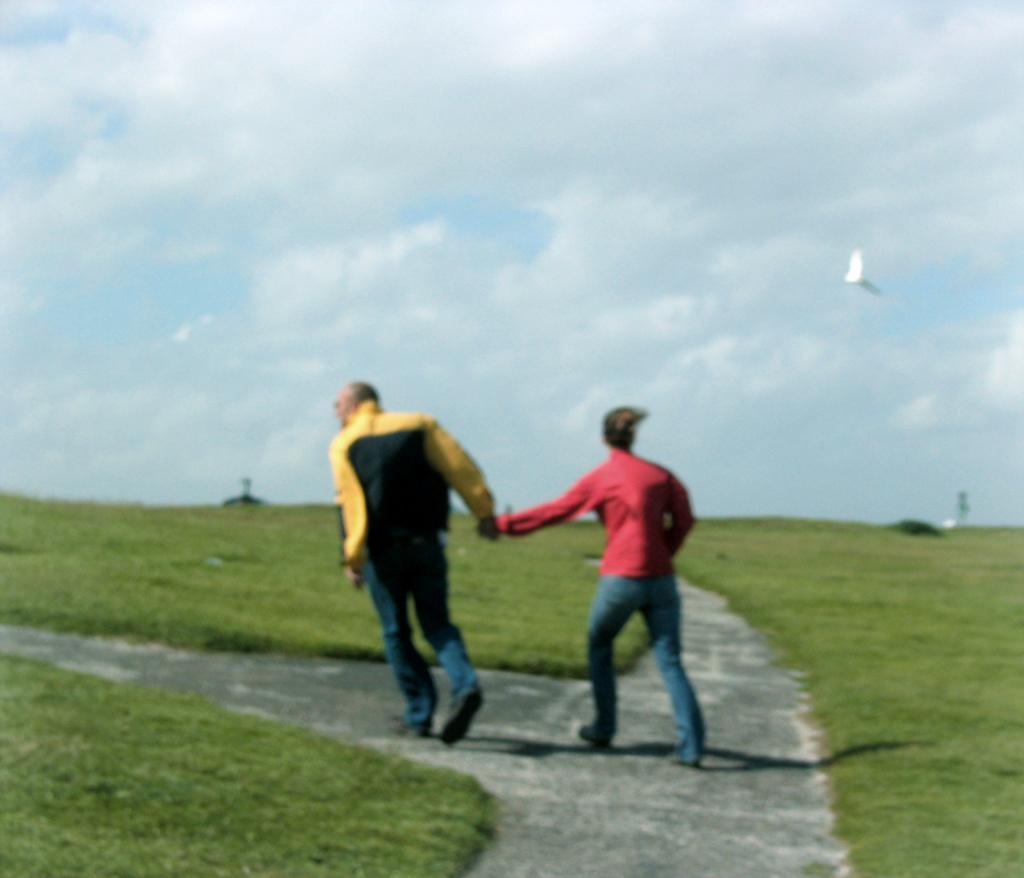Describe this image in one or two sentences. This image is clicked outside. There are two persons in this image. They are men. There is a bird on the right side. There is grass in this image. There is sky at the top. 